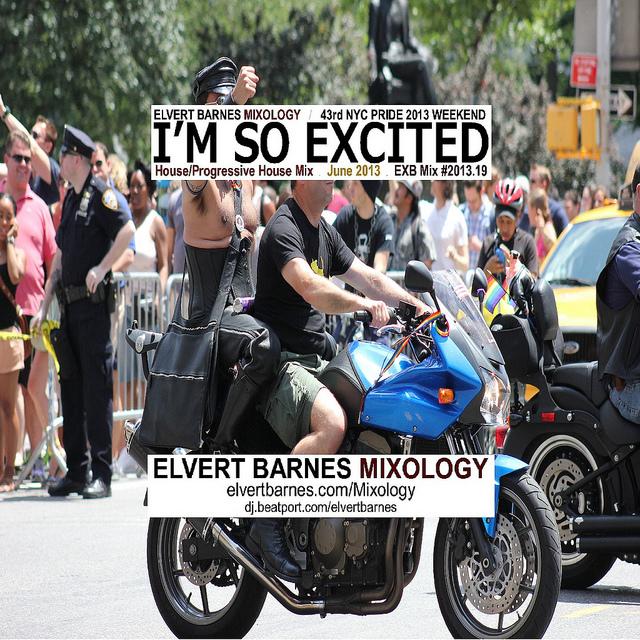What color is the box on the pole on the right side of the photo?
Concise answer only. Yellow. What is the website?
Be succinct. Elvertbarnescom/mixology. Is the man on the blue bike a police officer?
Quick response, please. No. 